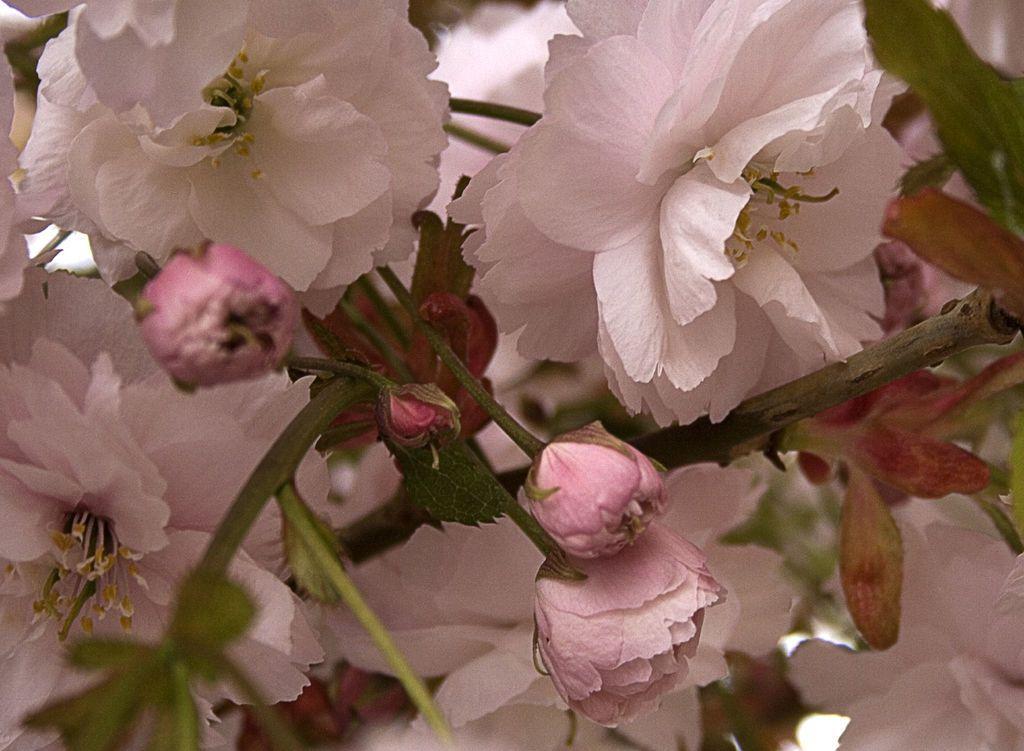Can you describe this image briefly? In this image we can see group of flowers on stems of plants. 